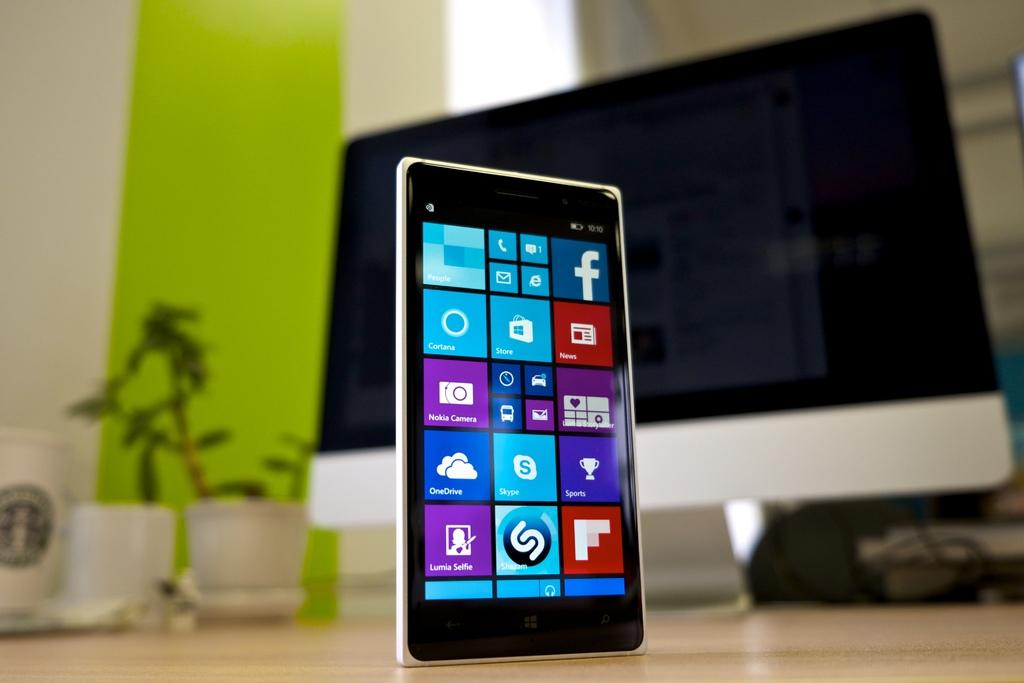<image>
Summarize the visual content of the image. A phone screen displays several apps to choose from, including Skype, OneDrive, and Store. 